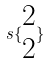<formula> <loc_0><loc_0><loc_500><loc_500>s \{ \begin{matrix} 2 \\ 2 \end{matrix} \}</formula> 